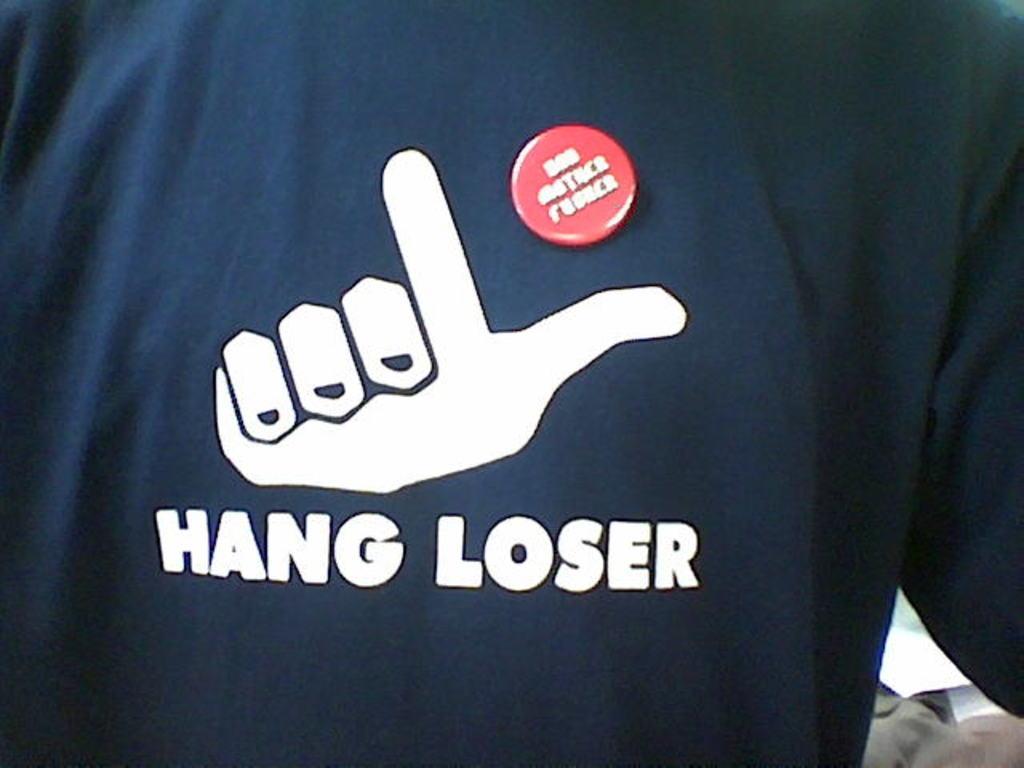Could you give a brief overview of what you see in this image? In the image we can see t-shirt and a symbol, this is a text. 